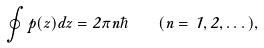Convert formula to latex. <formula><loc_0><loc_0><loc_500><loc_500>\oint p ( z ) d z = 2 \pi n \hbar { \quad } ( n = 1 , 2 , \dots ) ,</formula> 